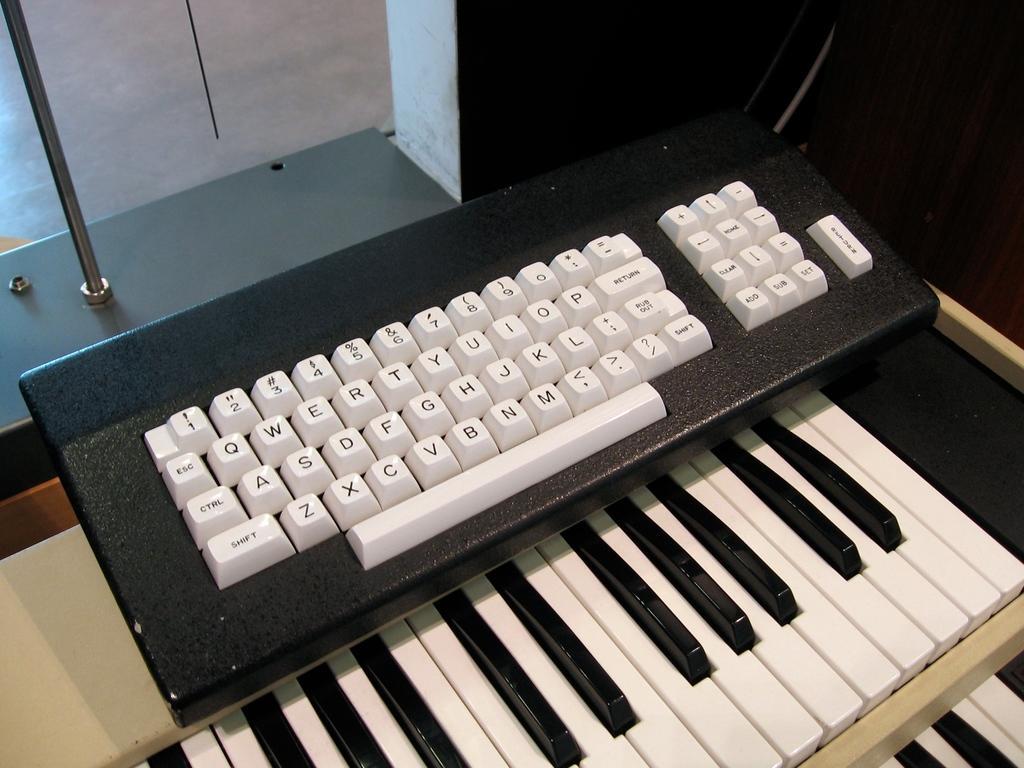How would you summarize this image in a sentence or two? In this picture we can see a keyboard and under this keyboard we have a piano keyboard of two steps and in the background we can see wall, pole and it is dark. 